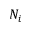<formula> <loc_0><loc_0><loc_500><loc_500>N _ { i }</formula> 